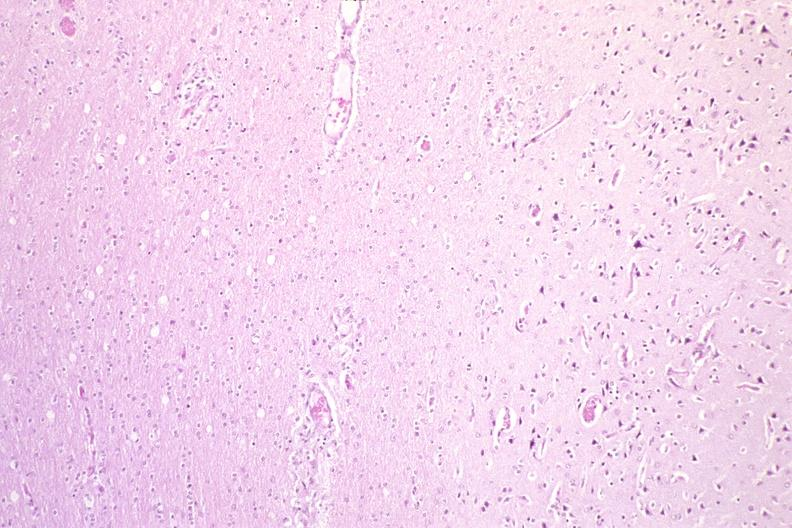s muscle atrophy present?
Answer the question using a single word or phrase. No 